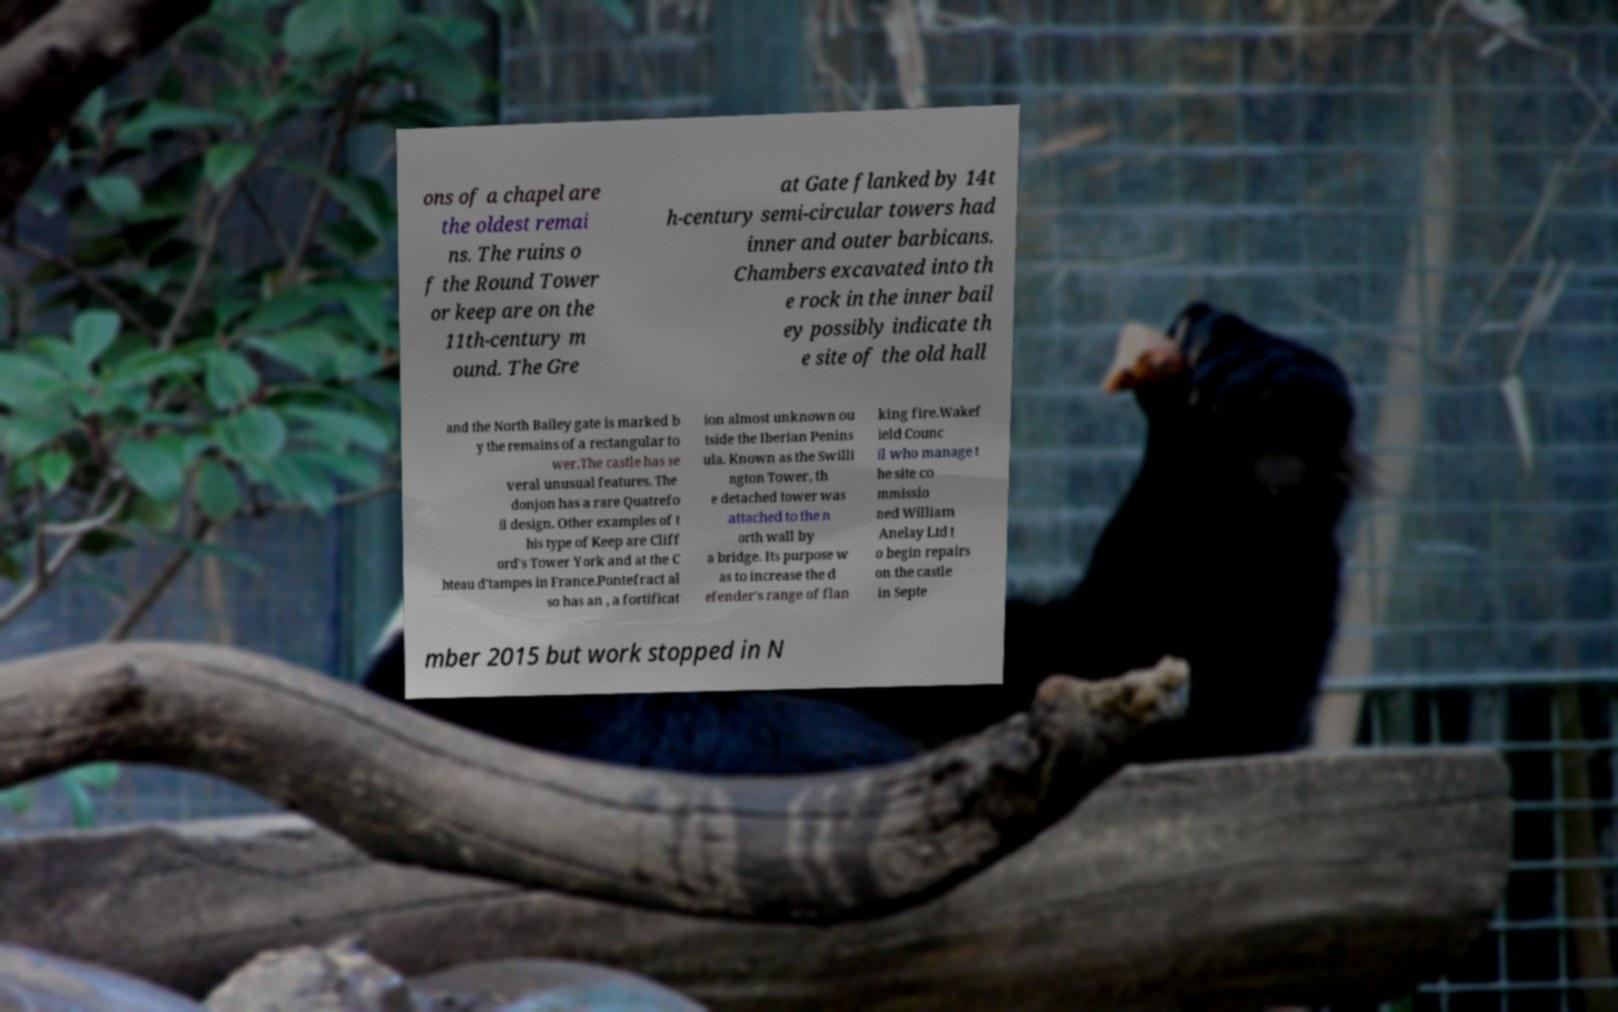What messages or text are displayed in this image? I need them in a readable, typed format. ons of a chapel are the oldest remai ns. The ruins o f the Round Tower or keep are on the 11th-century m ound. The Gre at Gate flanked by 14t h-century semi-circular towers had inner and outer barbicans. Chambers excavated into th e rock in the inner bail ey possibly indicate th e site of the old hall and the North Bailey gate is marked b y the remains of a rectangular to wer.The castle has se veral unusual features. The donjon has a rare Quatrefo il design. Other examples of t his type of Keep are Cliff ord's Tower York and at the C hteau d'tampes in France.Pontefract al so has an , a fortificat ion almost unknown ou tside the Iberian Penins ula. Known as the Swilli ngton Tower, th e detached tower was attached to the n orth wall by a bridge. Its purpose w as to increase the d efender's range of flan king fire.Wakef ield Counc il who manage t he site co mmissio ned William Anelay Ltd t o begin repairs on the castle in Septe mber 2015 but work stopped in N 